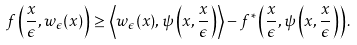<formula> <loc_0><loc_0><loc_500><loc_500>f \left ( \frac { x } { \epsilon } , w _ { \epsilon } ( x ) \right ) \geq \left \langle w _ { \epsilon } ( x ) , \psi \left ( x , \frac { x } { \epsilon } \right ) \right \rangle - f ^ { * } \left ( \frac { x } { \epsilon } , \psi \left ( x , \frac { x } { \epsilon } \right ) \right ) .</formula> 